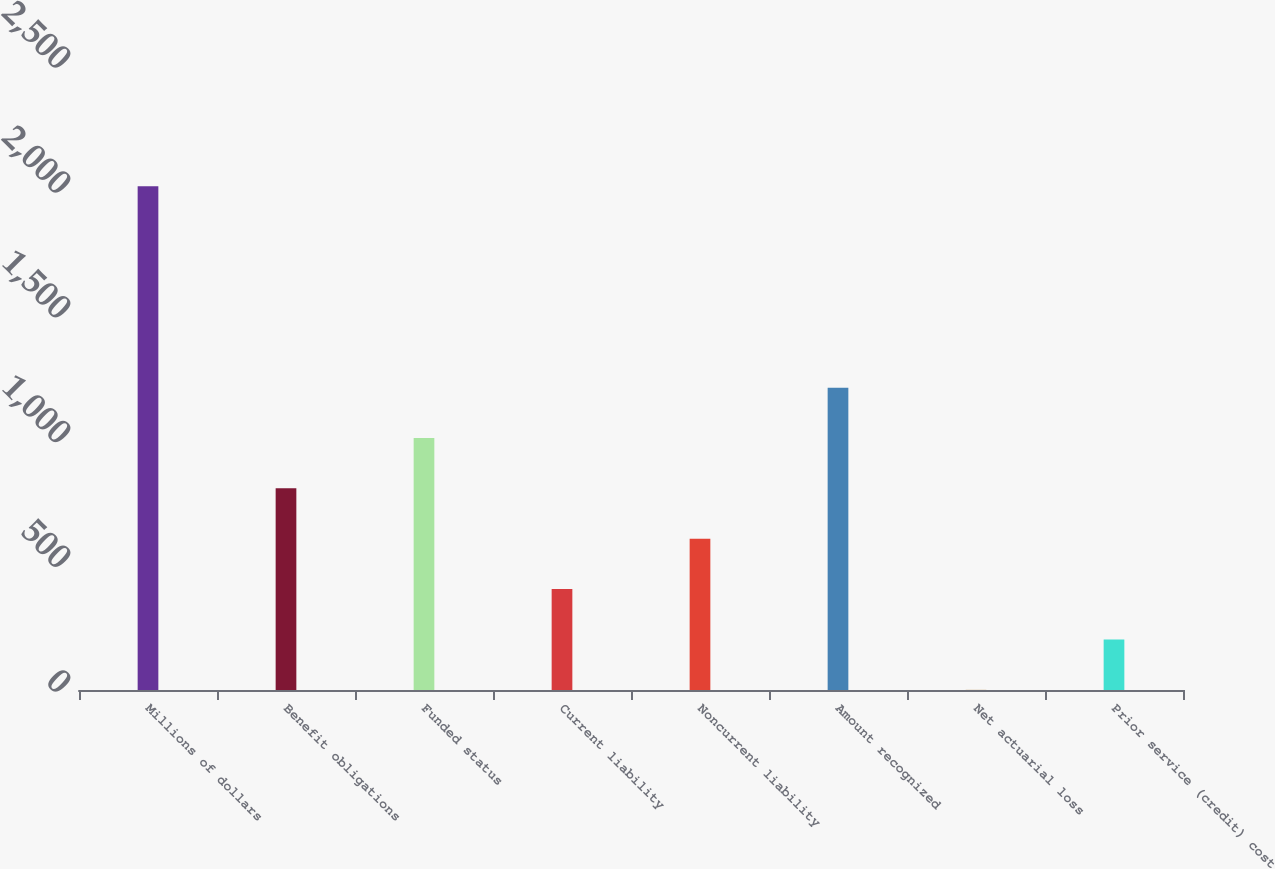<chart> <loc_0><loc_0><loc_500><loc_500><bar_chart><fcel>Millions of dollars<fcel>Benefit obligations<fcel>Funded status<fcel>Current liability<fcel>Noncurrent liability<fcel>Amount recognized<fcel>Net actuarial loss<fcel>Prior service (credit) cost<nl><fcel>2018<fcel>807.8<fcel>1009.5<fcel>404.4<fcel>606.1<fcel>1211.2<fcel>1<fcel>202.7<nl></chart> 